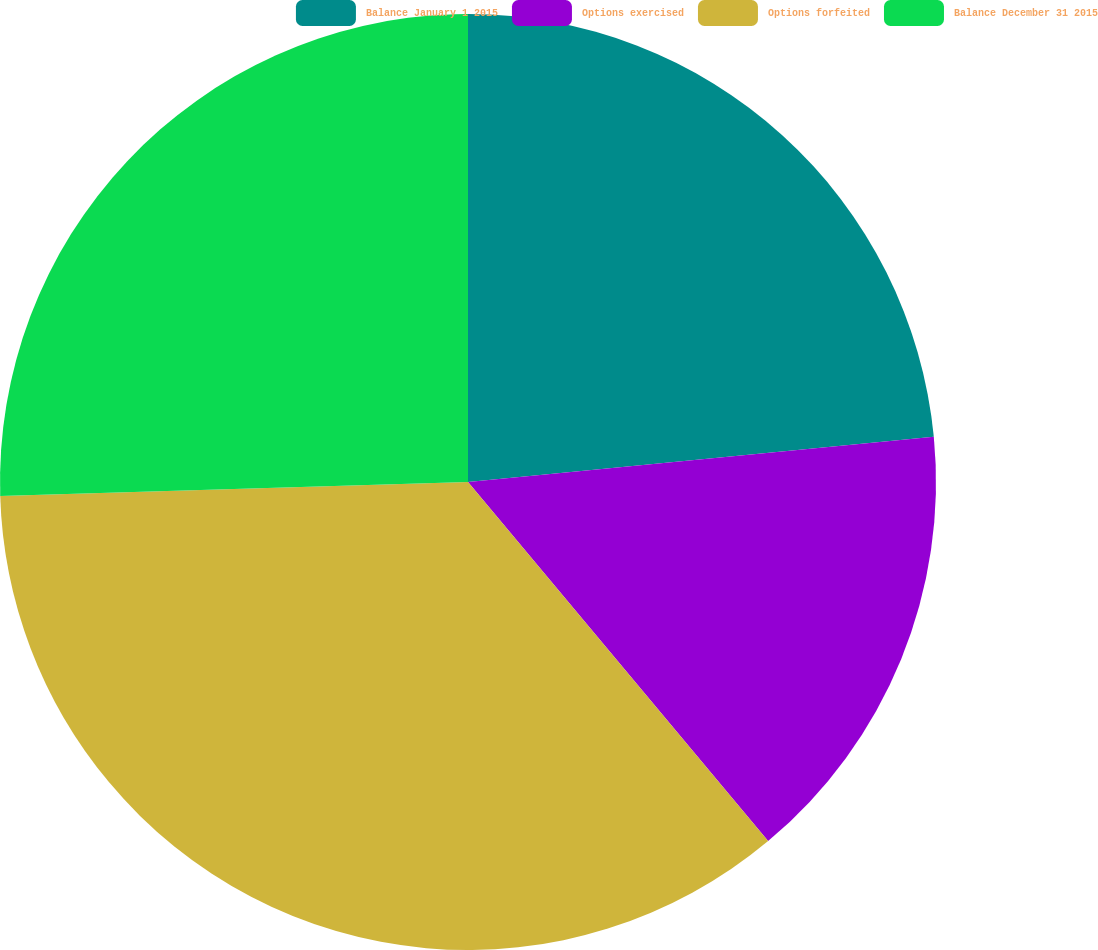Convert chart. <chart><loc_0><loc_0><loc_500><loc_500><pie_chart><fcel>Balance January 1 2015<fcel>Options exercised<fcel>Options forfeited<fcel>Balance December 31 2015<nl><fcel>23.46%<fcel>15.46%<fcel>35.6%<fcel>25.48%<nl></chart> 